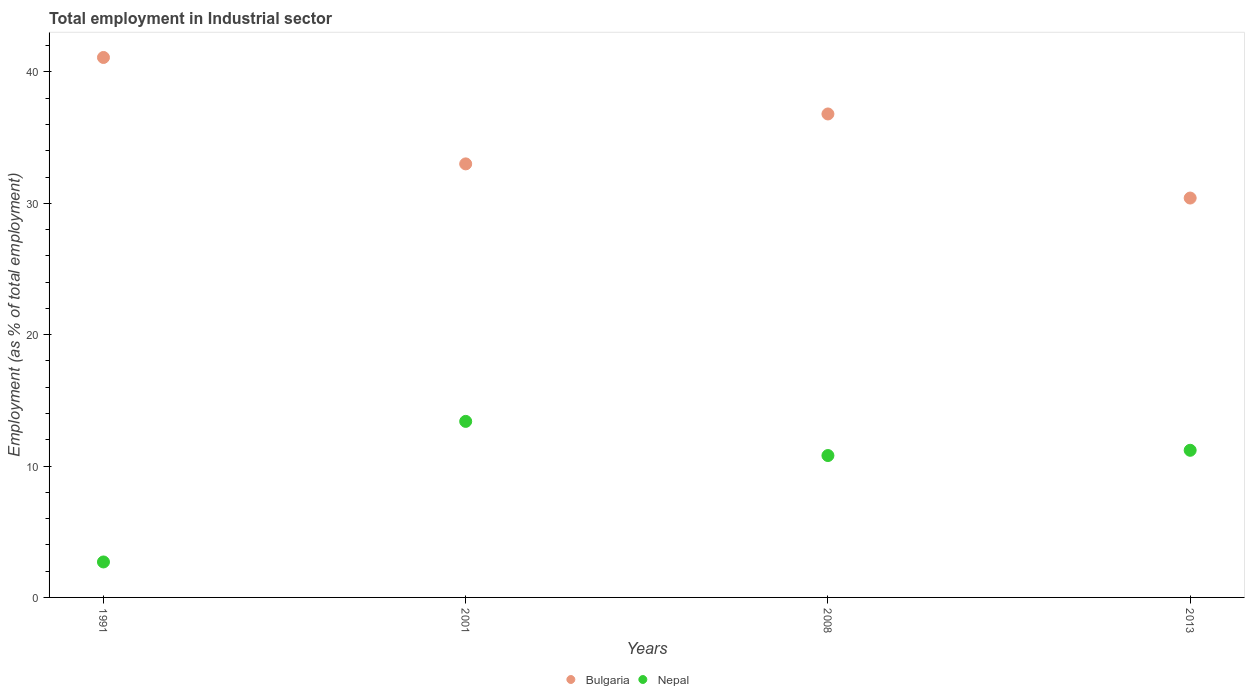What is the employment in industrial sector in Nepal in 2013?
Your answer should be very brief. 11.2. Across all years, what is the maximum employment in industrial sector in Nepal?
Offer a very short reply. 13.4. Across all years, what is the minimum employment in industrial sector in Nepal?
Offer a terse response. 2.7. In which year was the employment in industrial sector in Bulgaria maximum?
Make the answer very short. 1991. In which year was the employment in industrial sector in Nepal minimum?
Your answer should be very brief. 1991. What is the total employment in industrial sector in Bulgaria in the graph?
Make the answer very short. 141.3. What is the difference between the employment in industrial sector in Bulgaria in 1991 and that in 2008?
Offer a very short reply. 4.3. What is the difference between the employment in industrial sector in Bulgaria in 2013 and the employment in industrial sector in Nepal in 2008?
Make the answer very short. 19.6. What is the average employment in industrial sector in Bulgaria per year?
Your response must be concise. 35.32. In the year 2008, what is the difference between the employment in industrial sector in Nepal and employment in industrial sector in Bulgaria?
Offer a very short reply. -26. In how many years, is the employment in industrial sector in Nepal greater than 22 %?
Ensure brevity in your answer.  0. What is the ratio of the employment in industrial sector in Nepal in 1991 to that in 2008?
Provide a succinct answer. 0.25. Is the employment in industrial sector in Nepal in 2001 less than that in 2013?
Provide a succinct answer. No. Is the difference between the employment in industrial sector in Nepal in 2008 and 2013 greater than the difference between the employment in industrial sector in Bulgaria in 2008 and 2013?
Your answer should be very brief. No. What is the difference between the highest and the second highest employment in industrial sector in Bulgaria?
Give a very brief answer. 4.3. What is the difference between the highest and the lowest employment in industrial sector in Nepal?
Provide a succinct answer. 10.7. In how many years, is the employment in industrial sector in Bulgaria greater than the average employment in industrial sector in Bulgaria taken over all years?
Keep it short and to the point. 2. Is the sum of the employment in industrial sector in Bulgaria in 1991 and 2001 greater than the maximum employment in industrial sector in Nepal across all years?
Keep it short and to the point. Yes. Is the employment in industrial sector in Nepal strictly greater than the employment in industrial sector in Bulgaria over the years?
Keep it short and to the point. No. Is the employment in industrial sector in Bulgaria strictly less than the employment in industrial sector in Nepal over the years?
Make the answer very short. No. How many years are there in the graph?
Your response must be concise. 4. Does the graph contain any zero values?
Provide a short and direct response. No. Where does the legend appear in the graph?
Provide a succinct answer. Bottom center. How many legend labels are there?
Provide a succinct answer. 2. What is the title of the graph?
Provide a short and direct response. Total employment in Industrial sector. Does "Cote d'Ivoire" appear as one of the legend labels in the graph?
Your answer should be very brief. No. What is the label or title of the X-axis?
Your answer should be very brief. Years. What is the label or title of the Y-axis?
Make the answer very short. Employment (as % of total employment). What is the Employment (as % of total employment) in Bulgaria in 1991?
Provide a succinct answer. 41.1. What is the Employment (as % of total employment) of Nepal in 1991?
Your answer should be compact. 2.7. What is the Employment (as % of total employment) of Nepal in 2001?
Provide a short and direct response. 13.4. What is the Employment (as % of total employment) of Bulgaria in 2008?
Your answer should be very brief. 36.8. What is the Employment (as % of total employment) of Nepal in 2008?
Provide a short and direct response. 10.8. What is the Employment (as % of total employment) of Bulgaria in 2013?
Give a very brief answer. 30.4. What is the Employment (as % of total employment) in Nepal in 2013?
Your answer should be very brief. 11.2. Across all years, what is the maximum Employment (as % of total employment) of Bulgaria?
Keep it short and to the point. 41.1. Across all years, what is the maximum Employment (as % of total employment) in Nepal?
Your answer should be very brief. 13.4. Across all years, what is the minimum Employment (as % of total employment) in Bulgaria?
Make the answer very short. 30.4. Across all years, what is the minimum Employment (as % of total employment) of Nepal?
Provide a short and direct response. 2.7. What is the total Employment (as % of total employment) of Bulgaria in the graph?
Your response must be concise. 141.3. What is the total Employment (as % of total employment) in Nepal in the graph?
Offer a terse response. 38.1. What is the difference between the Employment (as % of total employment) in Bulgaria in 1991 and that in 2001?
Provide a short and direct response. 8.1. What is the difference between the Employment (as % of total employment) of Bulgaria in 1991 and that in 2008?
Your response must be concise. 4.3. What is the difference between the Employment (as % of total employment) in Nepal in 1991 and that in 2008?
Offer a terse response. -8.1. What is the difference between the Employment (as % of total employment) of Bulgaria in 1991 and that in 2013?
Make the answer very short. 10.7. What is the difference between the Employment (as % of total employment) of Bulgaria in 2001 and that in 2008?
Ensure brevity in your answer.  -3.8. What is the difference between the Employment (as % of total employment) in Nepal in 2001 and that in 2008?
Provide a succinct answer. 2.6. What is the difference between the Employment (as % of total employment) in Nepal in 2001 and that in 2013?
Offer a terse response. 2.2. What is the difference between the Employment (as % of total employment) in Bulgaria in 2008 and that in 2013?
Your answer should be very brief. 6.4. What is the difference between the Employment (as % of total employment) in Nepal in 2008 and that in 2013?
Make the answer very short. -0.4. What is the difference between the Employment (as % of total employment) of Bulgaria in 1991 and the Employment (as % of total employment) of Nepal in 2001?
Your answer should be very brief. 27.7. What is the difference between the Employment (as % of total employment) in Bulgaria in 1991 and the Employment (as % of total employment) in Nepal in 2008?
Give a very brief answer. 30.3. What is the difference between the Employment (as % of total employment) of Bulgaria in 1991 and the Employment (as % of total employment) of Nepal in 2013?
Provide a succinct answer. 29.9. What is the difference between the Employment (as % of total employment) of Bulgaria in 2001 and the Employment (as % of total employment) of Nepal in 2008?
Offer a terse response. 22.2. What is the difference between the Employment (as % of total employment) of Bulgaria in 2001 and the Employment (as % of total employment) of Nepal in 2013?
Ensure brevity in your answer.  21.8. What is the difference between the Employment (as % of total employment) in Bulgaria in 2008 and the Employment (as % of total employment) in Nepal in 2013?
Keep it short and to the point. 25.6. What is the average Employment (as % of total employment) in Bulgaria per year?
Your answer should be very brief. 35.33. What is the average Employment (as % of total employment) in Nepal per year?
Your answer should be compact. 9.53. In the year 1991, what is the difference between the Employment (as % of total employment) of Bulgaria and Employment (as % of total employment) of Nepal?
Provide a short and direct response. 38.4. In the year 2001, what is the difference between the Employment (as % of total employment) of Bulgaria and Employment (as % of total employment) of Nepal?
Provide a succinct answer. 19.6. What is the ratio of the Employment (as % of total employment) in Bulgaria in 1991 to that in 2001?
Your answer should be very brief. 1.25. What is the ratio of the Employment (as % of total employment) in Nepal in 1991 to that in 2001?
Offer a very short reply. 0.2. What is the ratio of the Employment (as % of total employment) in Bulgaria in 1991 to that in 2008?
Provide a succinct answer. 1.12. What is the ratio of the Employment (as % of total employment) of Nepal in 1991 to that in 2008?
Your answer should be compact. 0.25. What is the ratio of the Employment (as % of total employment) of Bulgaria in 1991 to that in 2013?
Ensure brevity in your answer.  1.35. What is the ratio of the Employment (as % of total employment) in Nepal in 1991 to that in 2013?
Offer a terse response. 0.24. What is the ratio of the Employment (as % of total employment) in Bulgaria in 2001 to that in 2008?
Keep it short and to the point. 0.9. What is the ratio of the Employment (as % of total employment) in Nepal in 2001 to that in 2008?
Offer a terse response. 1.24. What is the ratio of the Employment (as % of total employment) in Bulgaria in 2001 to that in 2013?
Give a very brief answer. 1.09. What is the ratio of the Employment (as % of total employment) of Nepal in 2001 to that in 2013?
Offer a very short reply. 1.2. What is the ratio of the Employment (as % of total employment) of Bulgaria in 2008 to that in 2013?
Give a very brief answer. 1.21. What is the ratio of the Employment (as % of total employment) of Nepal in 2008 to that in 2013?
Your response must be concise. 0.96. 